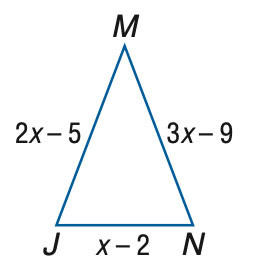Answer the mathemtical geometry problem and directly provide the correct option letter.
Question: Find x if \triangle J M N is an isosceles triangle with J M \cong M N.
Choices: A: 2 B: 3 C: 4 D: 4 C 